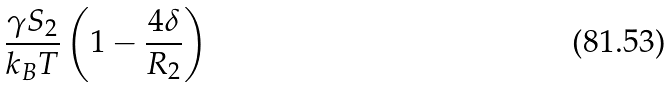Convert formula to latex. <formula><loc_0><loc_0><loc_500><loc_500>\frac { \gamma S _ { 2 } } { k _ { B } T } \left ( 1 - \frac { 4 \delta } { R _ { 2 } } \right )</formula> 